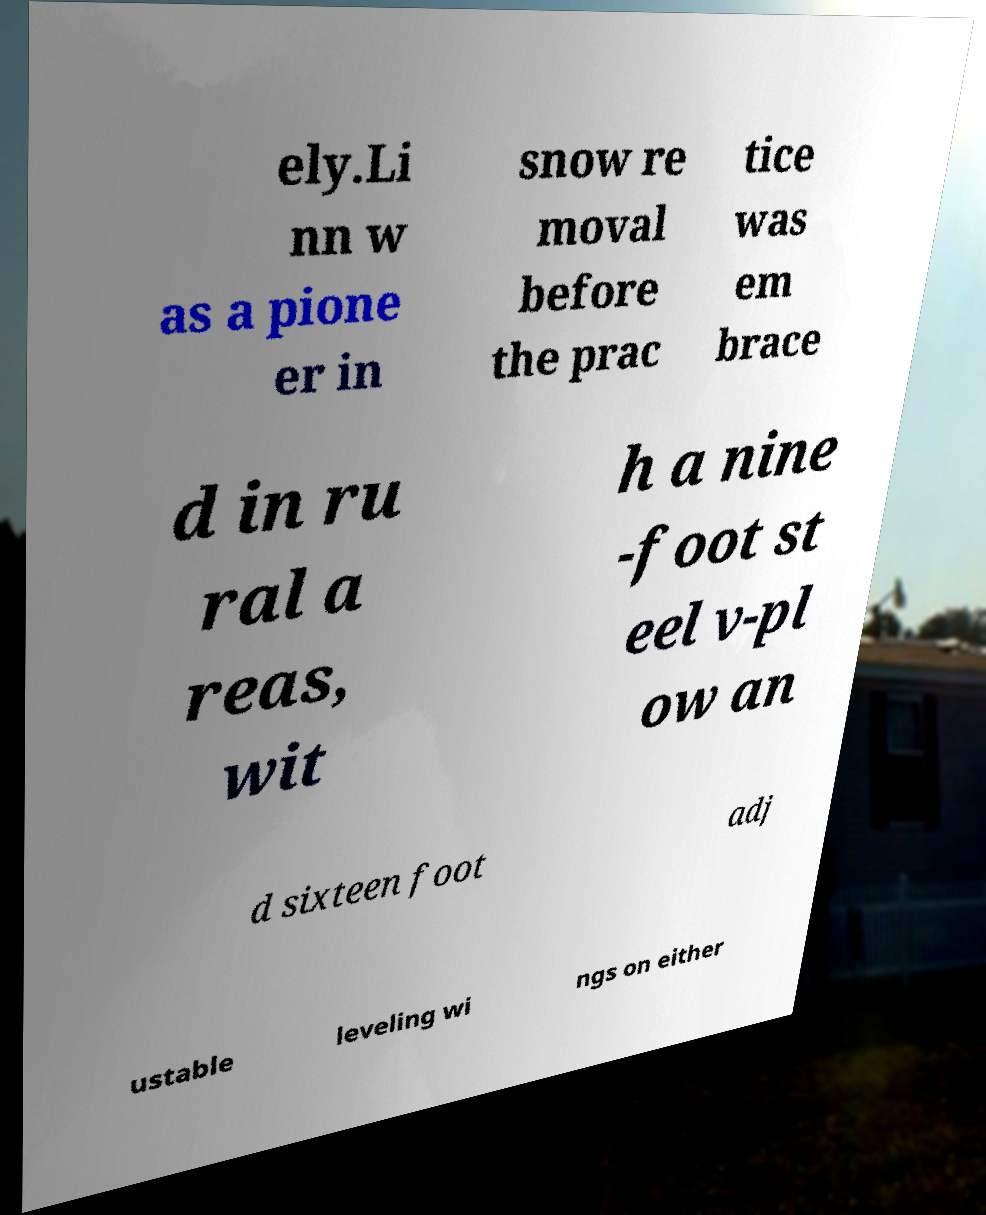I need the written content from this picture converted into text. Can you do that? ely.Li nn w as a pione er in snow re moval before the prac tice was em brace d in ru ral a reas, wit h a nine -foot st eel v-pl ow an d sixteen foot adj ustable leveling wi ngs on either 